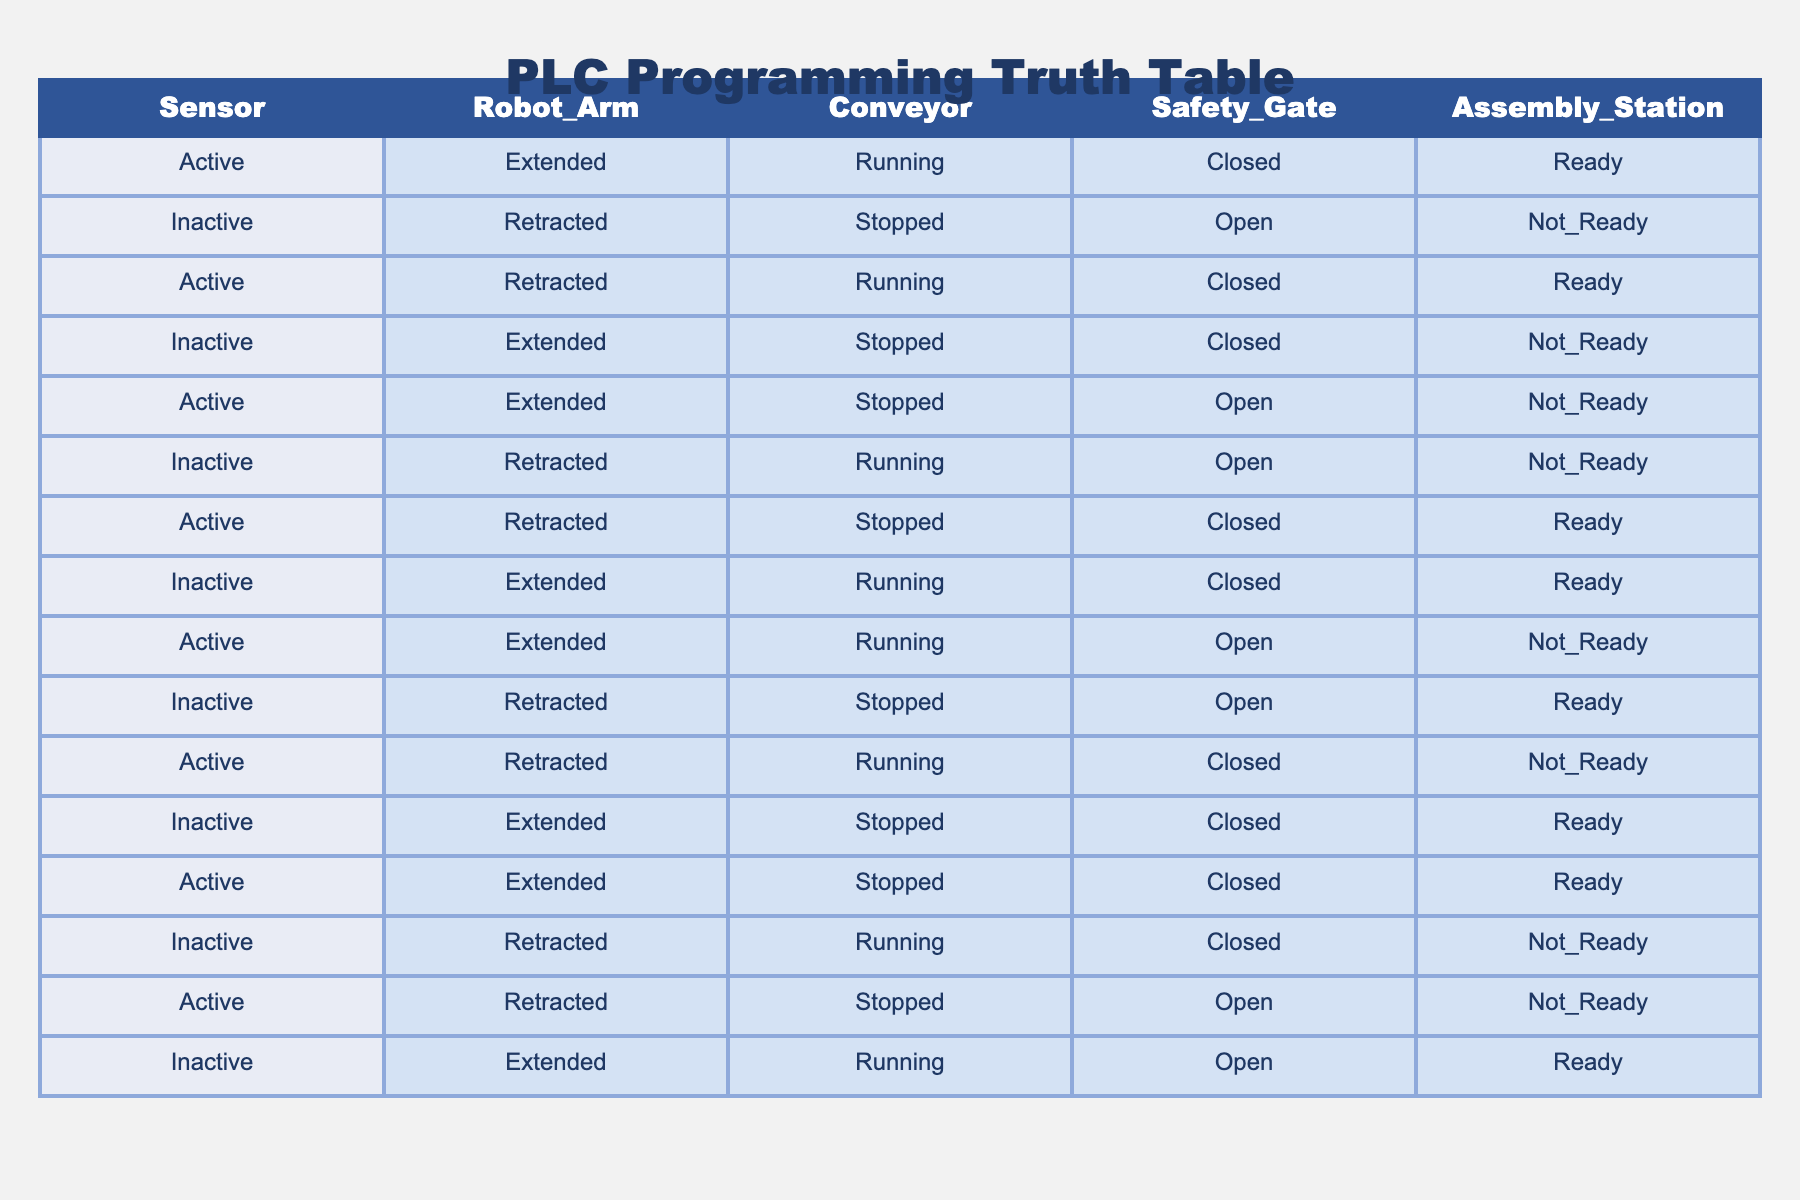What is the state of the Safety Gate when the Sensor is Active and the Robot Arm is Extended? From the table, when the Sensor is Active and the Robot Arm is Extended, we can look for matching rows. The first row shows that the Safety Gate is Closed.
Answer: Closed How many conditions indicate that the Assembly Station is Not Ready? We need to count the rows in which the Assembly Station is Not Ready. By checking the table, we find that there are 6 occurrences of Not Ready.
Answer: 6 Is the Conveyor Running when the Robot Arm is Retracted? To answer this, we check all rows where the Robot Arm is Retracted. The relevant rows show the Conveyor state as Running in 3 cases (1, 2, and 4) and Stopped in 1 case (row 6). Since it's possible for the Conveyor to be both Running and Stopped, the answer is not clearly defined as an exclusive fact. Therefore, it is not exclusively true that the Conveyor is Running when the Robot Arm is Retracted.
Answer: No What is the total number of times the Assembly Station is Ready when the Sensor is Active? We identify the rows where the Sensor is Active (1st, 3rd, 5th, 7th, 9th, 11th, 13th) and check the Assembly Station value in those rows: it is Ready in rows 1 (Ready), 3 (Ready), 7 (Ready), and 11 (Ready). Thus, the total count of Ready states in these cases is 4.
Answer: 4 Are there any instances with the Safety Gate Closed while the Conveyor is Stopped? We check rows for the Safety Gate being Closed and if the Conveyor is also Stopped. There are two rows, numbers 4 (Inactive, Extended, Stopped, Closed, Not Ready) which fits both conditions. Hence, there are instances where both conditions are met.
Answer: Yes What is the average state of the Robot Arm when the Safety Gate is Closed? We need to find all instances with the Safety Gate Closed. This occurs in rows 1, 4, 9, and 13. Analyzing these rows, we find that the Robot Arm state is Extended in rows 1, 9 and Retracted in rows 4 and 13. Since we have 3 Extended and 1 Retracted, the average could be interpreted (if we suppose that Extended=1 and Retracted=0) as mainly Extended. To be precise: 3/4 = 0.75 Extended on average.
Answer: Mostly Extended 